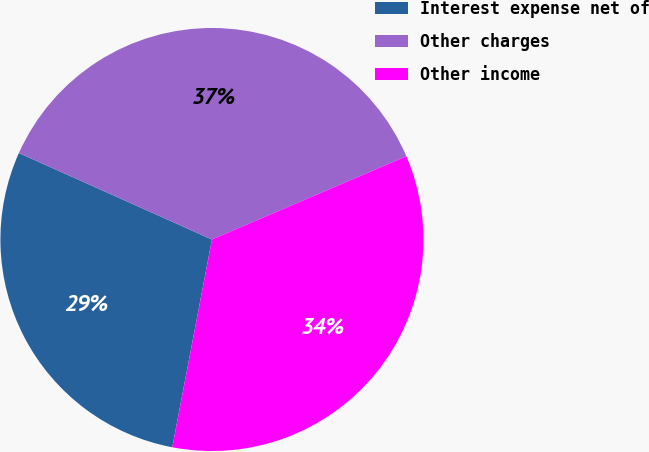Convert chart to OTSL. <chart><loc_0><loc_0><loc_500><loc_500><pie_chart><fcel>Interest expense net of<fcel>Other charges<fcel>Other income<nl><fcel>28.7%<fcel>36.86%<fcel>34.44%<nl></chart> 